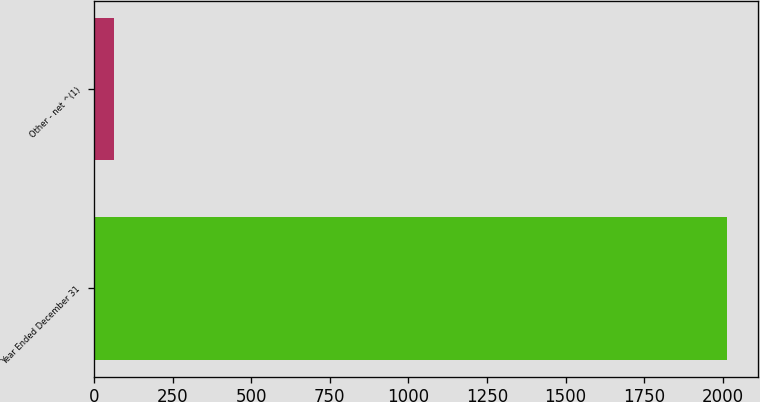Convert chart to OTSL. <chart><loc_0><loc_0><loc_500><loc_500><bar_chart><fcel>Year Ended December 31<fcel>Other - net ^(1)<nl><fcel>2012<fcel>62<nl></chart> 